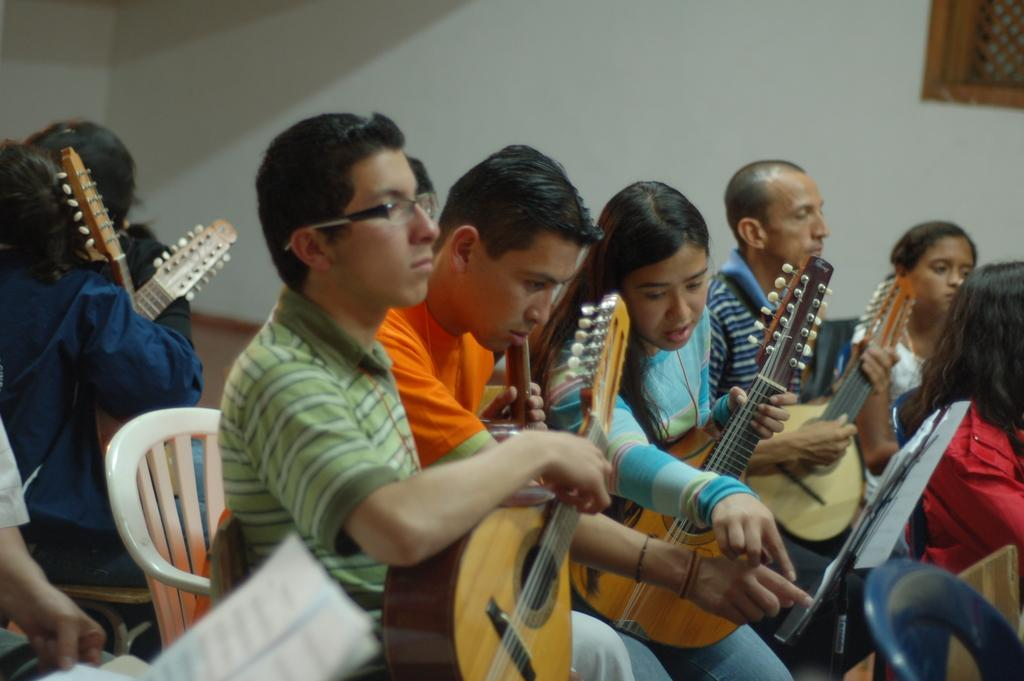What is happening in the image involving a group of people? There is a group of people in the image, and they are sitting on chairs. What are the people holding in the image? The people are holding guitars. What can be seen on the right side of the image? There is a wall on the right side of the image. What type of basket is being used for educational purposes in the image? There is no basket or educational activity present in the image. 